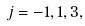Convert formula to latex. <formula><loc_0><loc_0><loc_500><loc_500>j = - 1 , 1 , 3 ,</formula> 